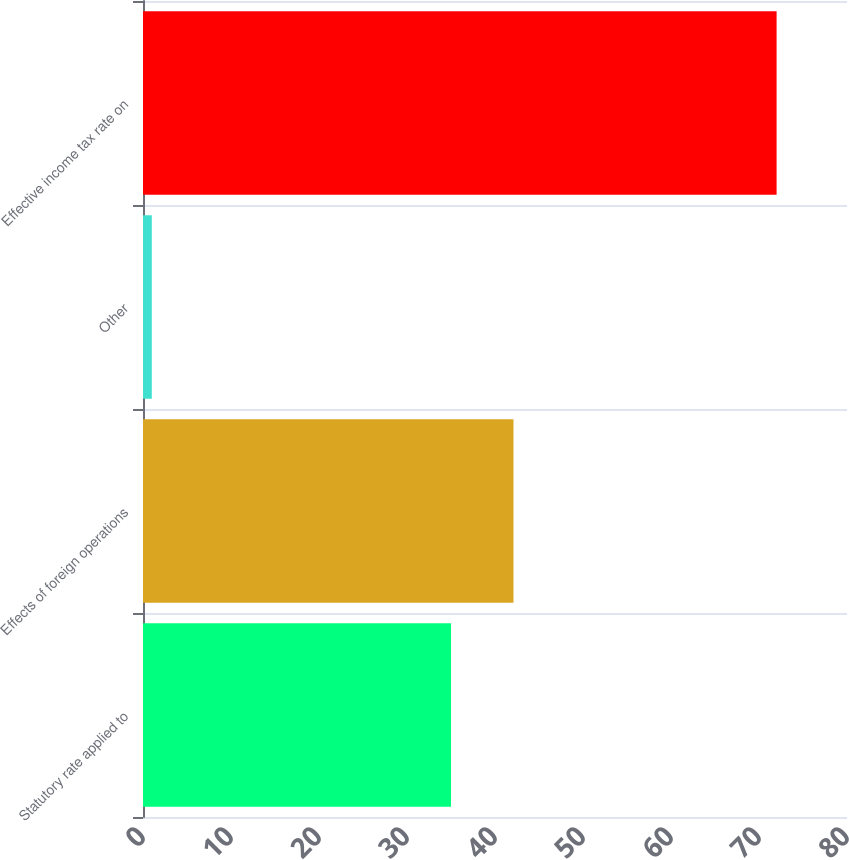Convert chart to OTSL. <chart><loc_0><loc_0><loc_500><loc_500><bar_chart><fcel>Statutory rate applied to<fcel>Effects of foreign operations<fcel>Other<fcel>Effective income tax rate on<nl><fcel>35<fcel>42.1<fcel>1<fcel>72<nl></chart> 